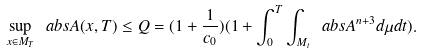<formula> <loc_0><loc_0><loc_500><loc_500>\sup _ { x \in M _ { T } } \ a b s { A ( x , T ) } \leq Q = ( 1 + \frac { 1 } { c _ { 0 } } ) ( 1 + \int _ { 0 } ^ { T } \int _ { M _ { t } } \ a b s { A } ^ { n + 3 } d \mu d t ) .</formula> 